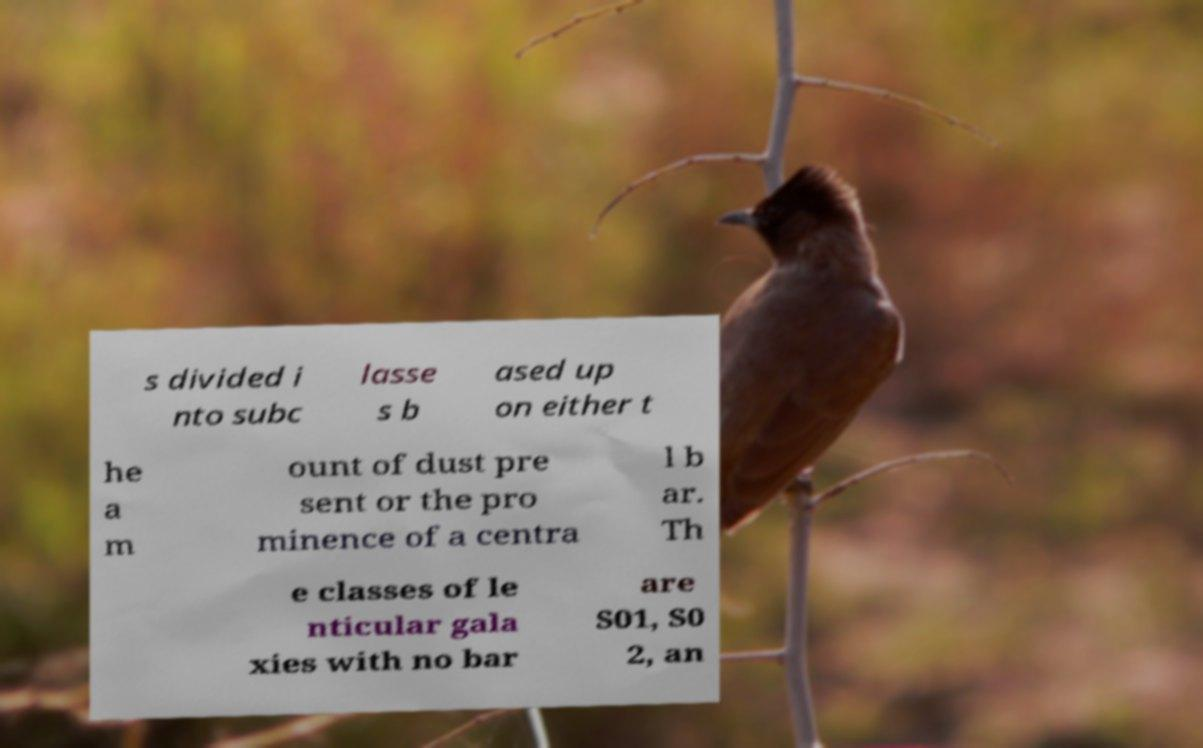I need the written content from this picture converted into text. Can you do that? s divided i nto subc lasse s b ased up on either t he a m ount of dust pre sent or the pro minence of a centra l b ar. Th e classes of le nticular gala xies with no bar are S01, S0 2, an 